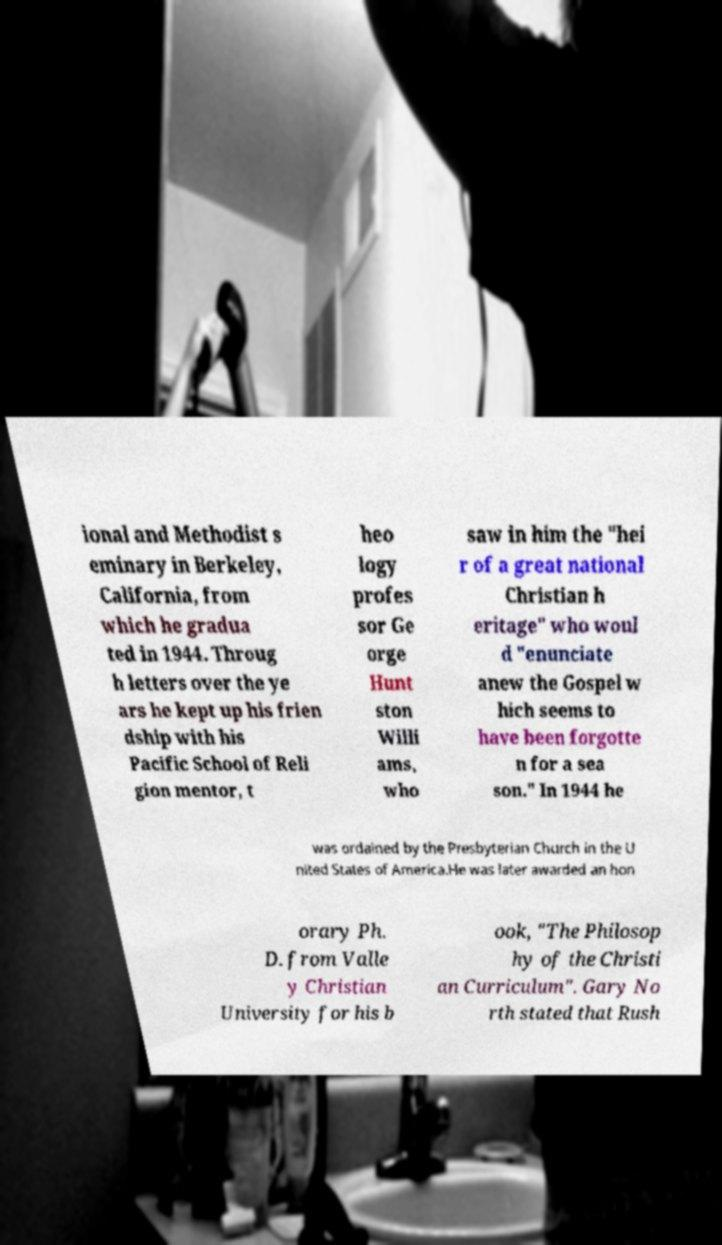Can you accurately transcribe the text from the provided image for me? ional and Methodist s eminary in Berkeley, California, from which he gradua ted in 1944. Throug h letters over the ye ars he kept up his frien dship with his Pacific School of Reli gion mentor, t heo logy profes sor Ge orge Hunt ston Willi ams, who saw in him the "hei r of a great national Christian h eritage" who woul d "enunciate anew the Gospel w hich seems to have been forgotte n for a sea son." In 1944 he was ordained by the Presbyterian Church in the U nited States of America.He was later awarded an hon orary Ph. D. from Valle y Christian University for his b ook, "The Philosop hy of the Christi an Curriculum". Gary No rth stated that Rush 